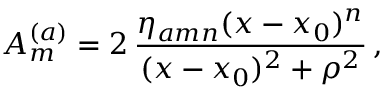<formula> <loc_0><loc_0><loc_500><loc_500>A _ { m } ^ { ( a ) } = 2 \, \frac { \eta _ { a m n } ( x - x _ { 0 } ) ^ { n } } { ( x - x _ { 0 } ) ^ { 2 } + \rho ^ { 2 } } \, ,</formula> 